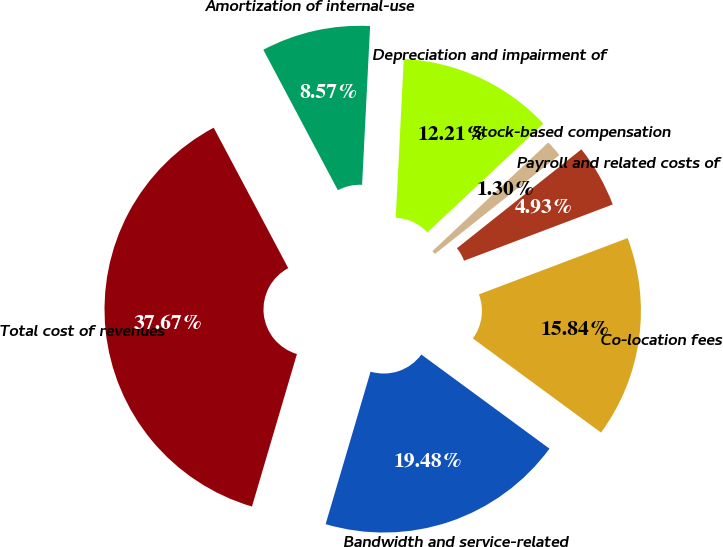<chart> <loc_0><loc_0><loc_500><loc_500><pie_chart><fcel>Bandwidth and service-related<fcel>Co-location fees<fcel>Payroll and related costs of<fcel>Stock-based compensation<fcel>Depreciation and impairment of<fcel>Amortization of internal-use<fcel>Total cost of revenues<nl><fcel>19.48%<fcel>15.84%<fcel>4.93%<fcel>1.3%<fcel>12.21%<fcel>8.57%<fcel>37.67%<nl></chart> 